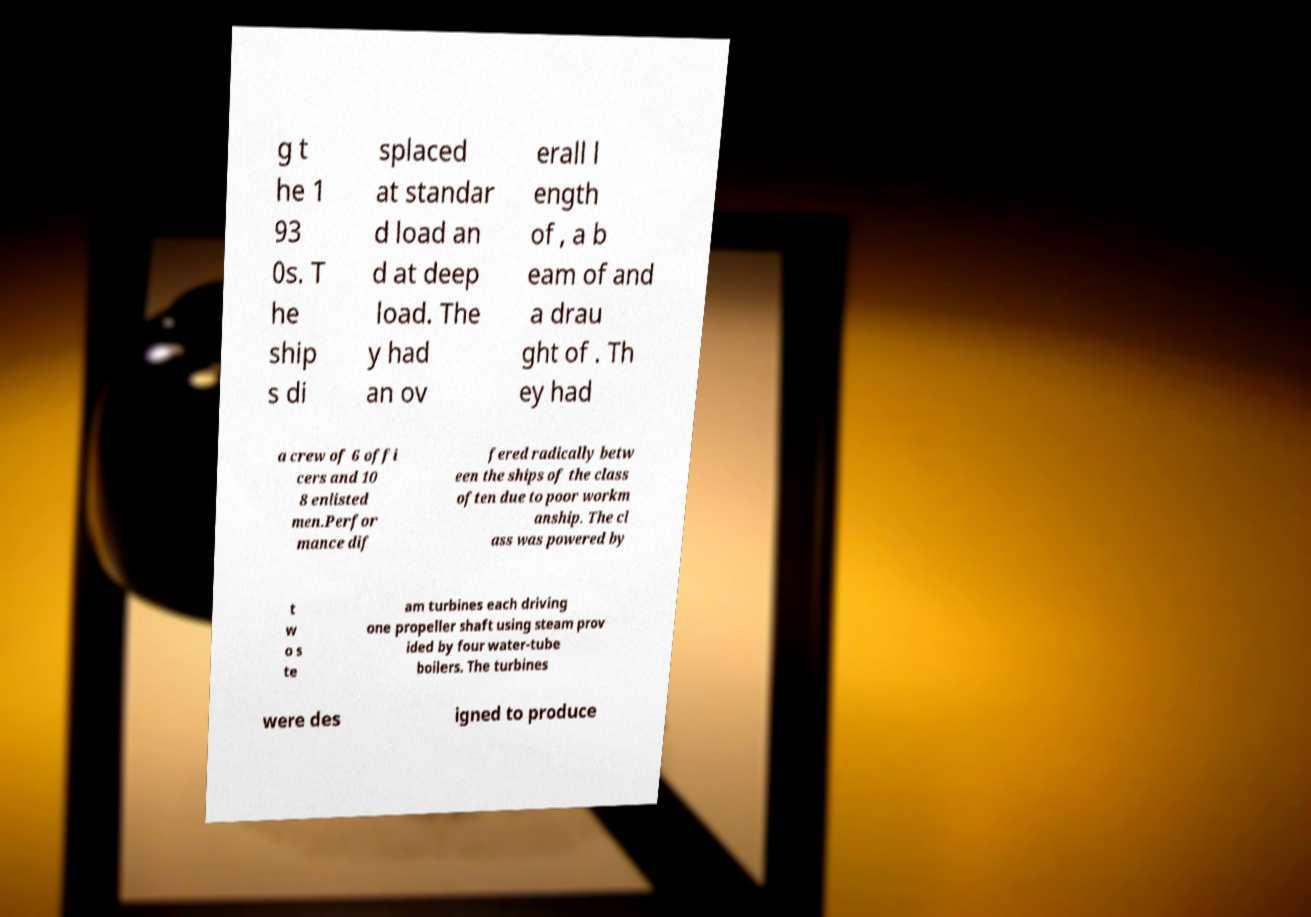For documentation purposes, I need the text within this image transcribed. Could you provide that? g t he 1 93 0s. T he ship s di splaced at standar d load an d at deep load. The y had an ov erall l ength of , a b eam of and a drau ght of . Th ey had a crew of 6 offi cers and 10 8 enlisted men.Perfor mance dif fered radically betw een the ships of the class often due to poor workm anship. The cl ass was powered by t w o s te am turbines each driving one propeller shaft using steam prov ided by four water-tube boilers. The turbines were des igned to produce 